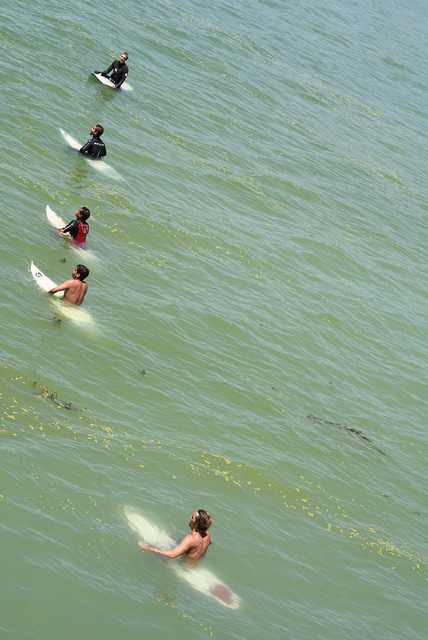What time of day does the lighting suggest this photo was taken? The lighting in the photo, with its soft and diffused quality, suggests that this could be either early morning or late afternoon, times which are often favored by surfers for their calmer winds and manageable waves. 